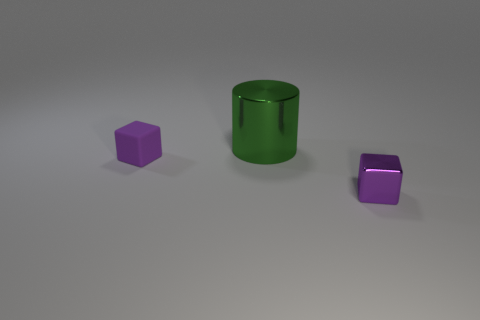Comparing the two purple cubes, is there any difference in their shades or textures? The two purple cubes seem to have the same color and matte texture, with no discernible difference in shade or texture.  Are the shapes of the objects perfect or do they have any irregularities? The shapes of the objects in the image appear to be perfect geometric forms without any visible irregularities or deformities. 